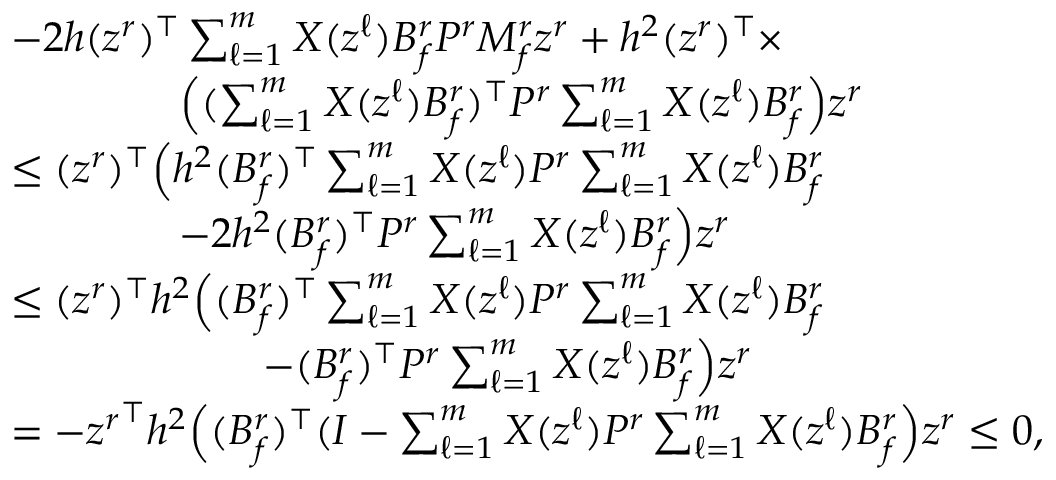<formula> <loc_0><loc_0><loc_500><loc_500>\begin{array} { r l } & { - 2 h ( z ^ { r } ) ^ { \top } \sum _ { \ell = 1 } ^ { m } X ( z ^ { \ell } ) B _ { f } ^ { r } P ^ { r } M _ { f } ^ { r } z ^ { r } + h ^ { 2 } ( z ^ { r } ) ^ { \top } \times } \\ & { \quad \left ( ( \sum _ { \ell = 1 } ^ { m } X ( z ^ { \ell } ) B _ { f } ^ { r } ) ^ { \top } P ^ { r } \sum _ { \ell = 1 } ^ { m } X ( z ^ { \ell } ) B _ { f } ^ { r } \right ) z ^ { r } } \\ & { \leq ( z ^ { r } ) ^ { \top } \left ( h ^ { 2 } ( B _ { f } ^ { r } ) ^ { \top } \sum _ { \ell = 1 } ^ { m } X ( z ^ { \ell } ) P ^ { r } \sum _ { \ell = 1 } ^ { m } X ( z ^ { \ell } ) B _ { f } ^ { r } } \\ & { - 2 h ^ { 2 } ( B _ { f } ^ { r } ) ^ { \top } P ^ { r } \sum _ { \ell = 1 } ^ { m } X ( z ^ { \ell } ) B _ { f } ^ { r } \right ) z ^ { r } } \\ & { \leq ( z ^ { r } ) ^ { \top } h ^ { 2 } \left ( ( B _ { f } ^ { r } ) ^ { \top } \sum _ { \ell = 1 } ^ { m } X ( z ^ { \ell } ) P ^ { r } \sum _ { \ell = 1 } ^ { m } X ( z ^ { \ell } ) B _ { f } ^ { r } } \\ & { - ( B _ { f } ^ { r } ) ^ { \top } P ^ { r } \sum _ { \ell = 1 } ^ { m } X ( z ^ { \ell } ) B _ { f } ^ { r } \right ) z ^ { r } } \\ & { = - { z ^ { r } } ^ { \top } h ^ { 2 } \left ( ( B _ { f } ^ { r } ) ^ { \top } ( I - \sum _ { \ell = 1 } ^ { m } X ( z ^ { \ell } ) P ^ { r } \sum _ { \ell = 1 } ^ { m } X ( z ^ { \ell } ) B _ { f } ^ { r } \right ) z ^ { r } \leq 0 , } \end{array}</formula> 